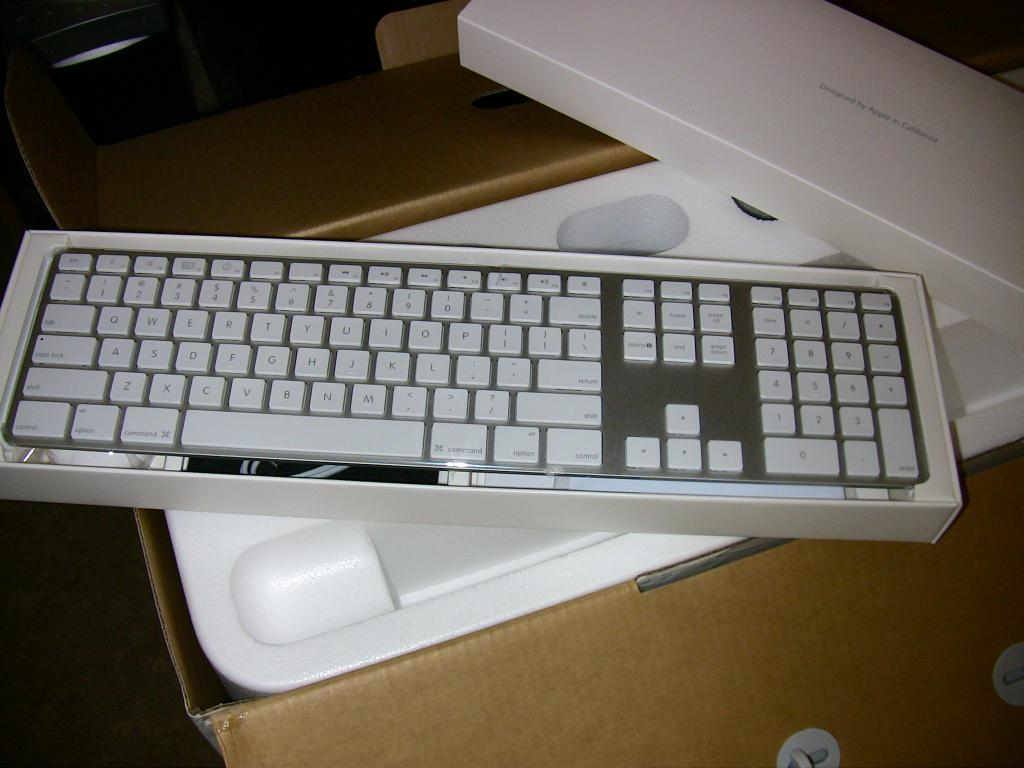What object is present in the image that has a keyboard on it? There is a box in the image that has a keyboard on it. Can you describe any other features of the box? Unfortunately, no other features of the box are mentioned in the provided facts. What part of the image is dark? The left side of the image is dark. Can you tell me how many horns are visible on the box in the image? There are no horns visible on the box in the image. What type of road is present in the image? There is no road present in the image. 